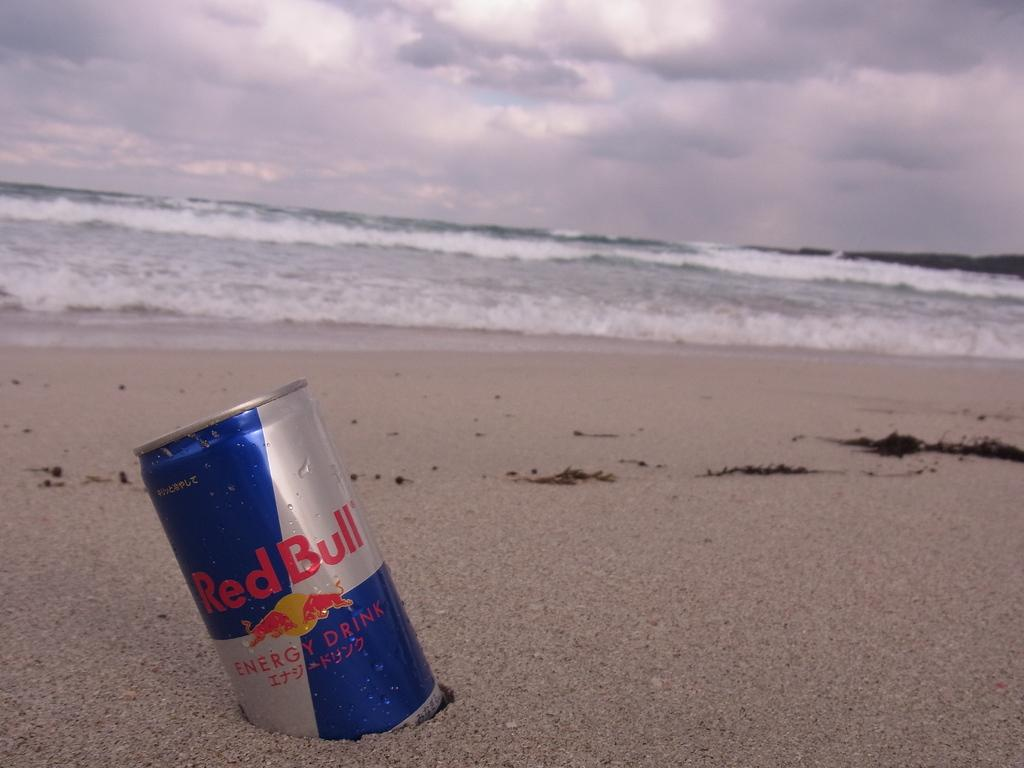<image>
Describe the image concisely. A can of Red Bull energy drink half buried in the sand 